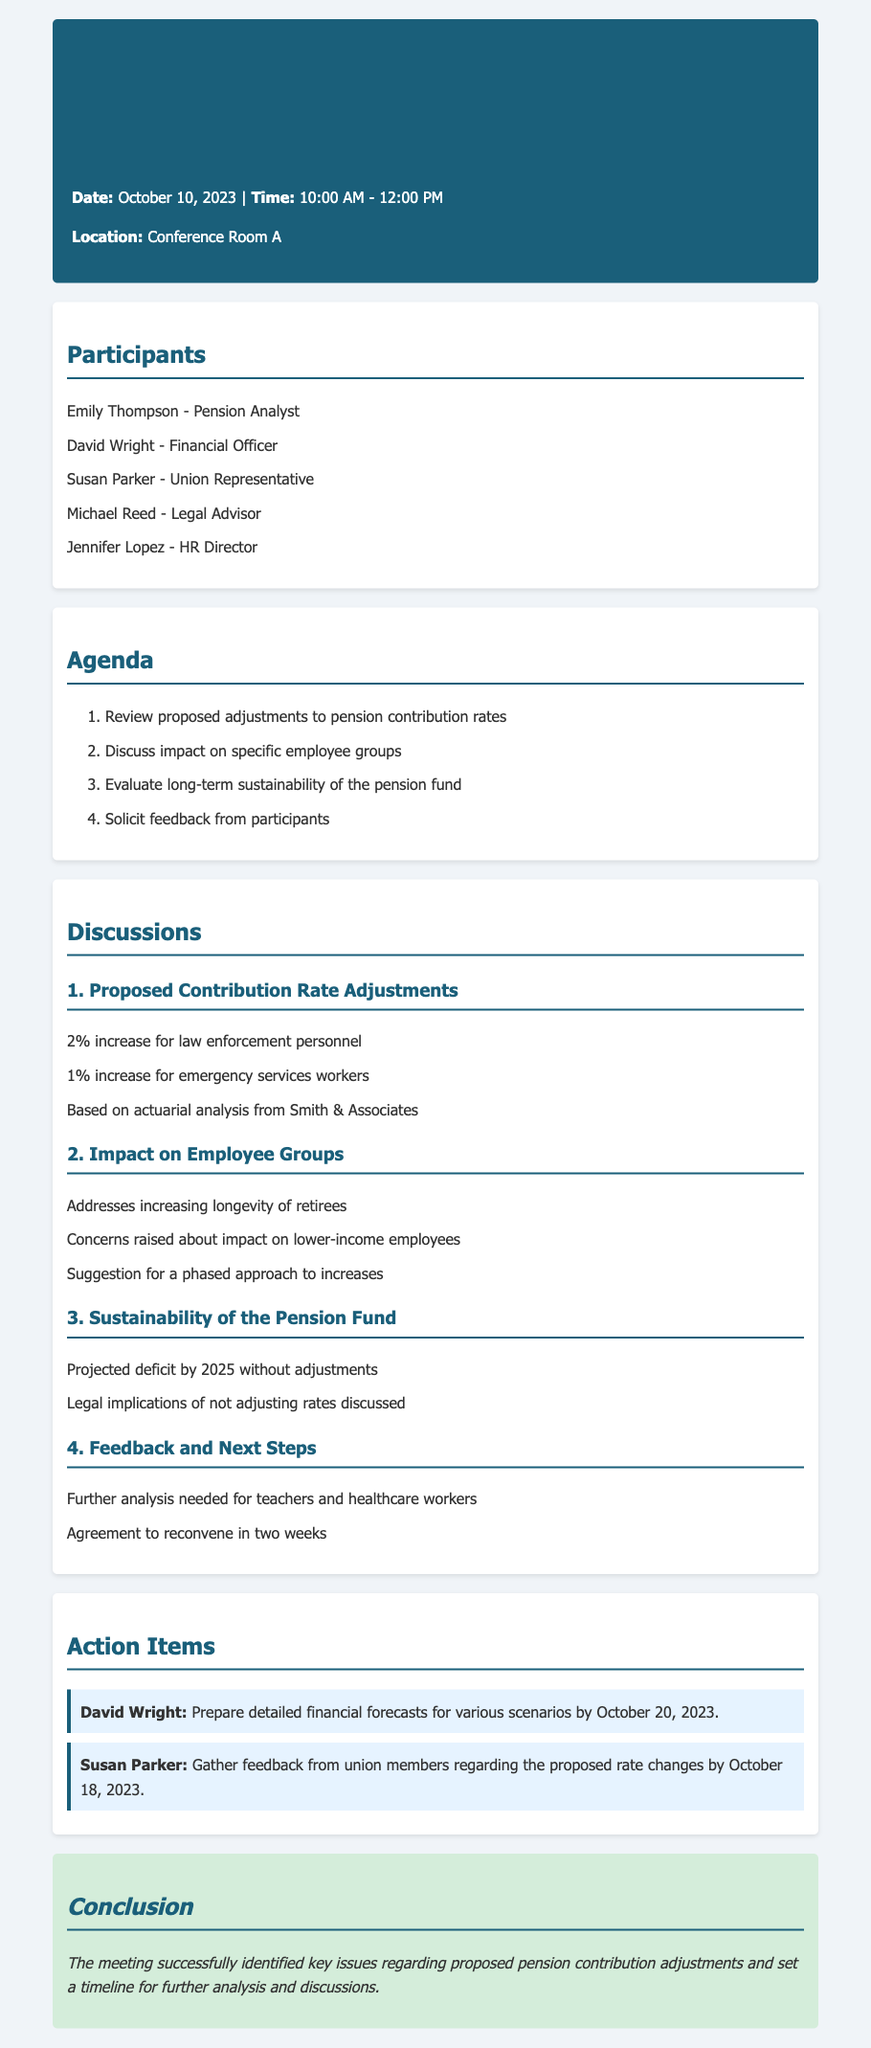what is the date of the meeting? The date of the meeting is mentioned at the beginning of the document.
Answer: October 10, 2023 who is the Pension Analyst present in the meeting? The participants section lists Emily Thompson as the Pension Analyst.
Answer: Emily Thompson what percentage increase is proposed for law enforcement personnel? The proposed adjustments for specific employee groups are detailed in the discussions section.
Answer: 2% what is the concern raised regarding lower-income employees? The impact on lower-income employees is discussed under the impact on employee groups.
Answer: Concerns raised about impact on lower-income employees by what date should David Wright prepare financial forecasts? The action items outline the responsibilities and deadlines assigned to participants.
Answer: October 20, 2023 what is the projected deficit year cited in the sustainability discussion? The sustainability section mentions a specific year for the projected deficit.
Answer: 2025 how many participants were listed in the meeting? The participants section contains a list, and we can count the number of names.
Answer: 5 what is the next meeting date mentioned in the discussion? The feedback and next steps section provides a timeline for the next meeting.
Answer: In two weeks 